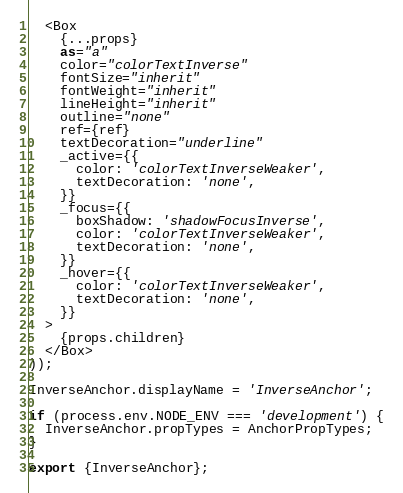Convert code to text. <code><loc_0><loc_0><loc_500><loc_500><_TypeScript_>  <Box
    {...props}
    as="a"
    color="colorTextInverse"
    fontSize="inherit"
    fontWeight="inherit"
    lineHeight="inherit"
    outline="none"
    ref={ref}
    textDecoration="underline"
    _active={{
      color: 'colorTextInverseWeaker',
      textDecoration: 'none',
    }}
    _focus={{
      boxShadow: 'shadowFocusInverse',
      color: 'colorTextInverseWeaker',
      textDecoration: 'none',
    }}
    _hover={{
      color: 'colorTextInverseWeaker',
      textDecoration: 'none',
    }}
  >
    {props.children}
  </Box>
));

InverseAnchor.displayName = 'InverseAnchor';

if (process.env.NODE_ENV === 'development') {
  InverseAnchor.propTypes = AnchorPropTypes;
}

export {InverseAnchor};
</code> 